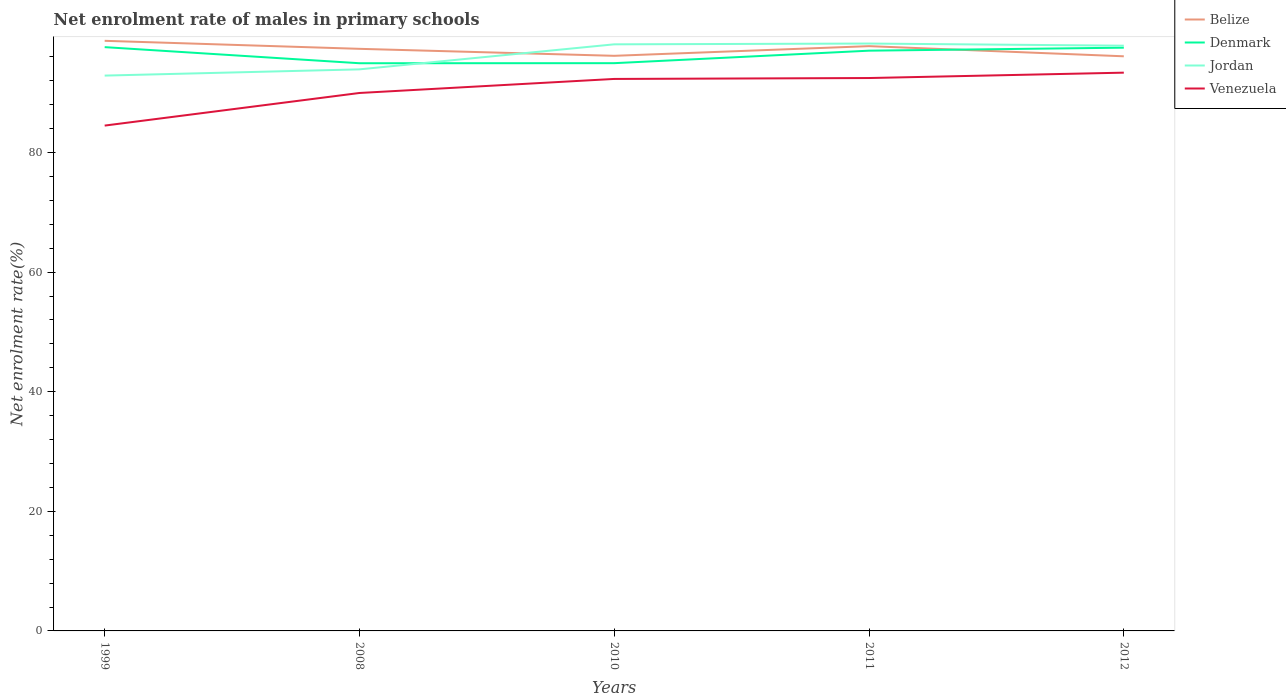Does the line corresponding to Venezuela intersect with the line corresponding to Belize?
Provide a succinct answer. No. Is the number of lines equal to the number of legend labels?
Ensure brevity in your answer.  Yes. Across all years, what is the maximum net enrolment rate of males in primary schools in Venezuela?
Offer a terse response. 84.51. In which year was the net enrolment rate of males in primary schools in Belize maximum?
Your response must be concise. 2012. What is the total net enrolment rate of males in primary schools in Venezuela in the graph?
Your answer should be compact. -2.35. What is the difference between the highest and the second highest net enrolment rate of males in primary schools in Belize?
Give a very brief answer. 2.59. What is the difference between the highest and the lowest net enrolment rate of males in primary schools in Denmark?
Your answer should be compact. 3. How many lines are there?
Provide a short and direct response. 4. How many years are there in the graph?
Keep it short and to the point. 5. Does the graph contain grids?
Give a very brief answer. No. Where does the legend appear in the graph?
Make the answer very short. Top right. How many legend labels are there?
Your answer should be compact. 4. What is the title of the graph?
Your response must be concise. Net enrolment rate of males in primary schools. What is the label or title of the X-axis?
Your response must be concise. Years. What is the label or title of the Y-axis?
Offer a very short reply. Net enrolment rate(%). What is the Net enrolment rate(%) of Belize in 1999?
Your answer should be compact. 98.68. What is the Net enrolment rate(%) in Denmark in 1999?
Offer a terse response. 97.63. What is the Net enrolment rate(%) in Jordan in 1999?
Your answer should be compact. 92.87. What is the Net enrolment rate(%) of Venezuela in 1999?
Your response must be concise. 84.51. What is the Net enrolment rate(%) of Belize in 2008?
Your response must be concise. 97.34. What is the Net enrolment rate(%) in Denmark in 2008?
Give a very brief answer. 94.93. What is the Net enrolment rate(%) in Jordan in 2008?
Your answer should be compact. 93.91. What is the Net enrolment rate(%) of Venezuela in 2008?
Offer a very short reply. 89.96. What is the Net enrolment rate(%) of Belize in 2010?
Keep it short and to the point. 96.17. What is the Net enrolment rate(%) of Denmark in 2010?
Offer a very short reply. 94.95. What is the Net enrolment rate(%) in Jordan in 2010?
Offer a very short reply. 98.1. What is the Net enrolment rate(%) of Venezuela in 2010?
Your response must be concise. 92.31. What is the Net enrolment rate(%) in Belize in 2011?
Offer a very short reply. 97.79. What is the Net enrolment rate(%) in Denmark in 2011?
Your response must be concise. 97.03. What is the Net enrolment rate(%) of Jordan in 2011?
Provide a succinct answer. 98.23. What is the Net enrolment rate(%) of Venezuela in 2011?
Your response must be concise. 92.46. What is the Net enrolment rate(%) in Belize in 2012?
Your answer should be very brief. 96.09. What is the Net enrolment rate(%) of Denmark in 2012?
Offer a very short reply. 97.54. What is the Net enrolment rate(%) of Jordan in 2012?
Your answer should be very brief. 97.87. What is the Net enrolment rate(%) in Venezuela in 2012?
Your answer should be compact. 93.36. Across all years, what is the maximum Net enrolment rate(%) of Belize?
Your answer should be very brief. 98.68. Across all years, what is the maximum Net enrolment rate(%) in Denmark?
Your answer should be compact. 97.63. Across all years, what is the maximum Net enrolment rate(%) of Jordan?
Offer a terse response. 98.23. Across all years, what is the maximum Net enrolment rate(%) in Venezuela?
Your response must be concise. 93.36. Across all years, what is the minimum Net enrolment rate(%) in Belize?
Make the answer very short. 96.09. Across all years, what is the minimum Net enrolment rate(%) in Denmark?
Make the answer very short. 94.93. Across all years, what is the minimum Net enrolment rate(%) in Jordan?
Your response must be concise. 92.87. Across all years, what is the minimum Net enrolment rate(%) in Venezuela?
Make the answer very short. 84.51. What is the total Net enrolment rate(%) in Belize in the graph?
Offer a terse response. 486.09. What is the total Net enrolment rate(%) in Denmark in the graph?
Your response must be concise. 482.08. What is the total Net enrolment rate(%) of Jordan in the graph?
Your response must be concise. 480.97. What is the total Net enrolment rate(%) of Venezuela in the graph?
Provide a succinct answer. 452.59. What is the difference between the Net enrolment rate(%) of Belize in 1999 and that in 2008?
Give a very brief answer. 1.34. What is the difference between the Net enrolment rate(%) in Denmark in 1999 and that in 2008?
Your answer should be very brief. 2.69. What is the difference between the Net enrolment rate(%) of Jordan in 1999 and that in 2008?
Offer a terse response. -1.04. What is the difference between the Net enrolment rate(%) of Venezuela in 1999 and that in 2008?
Make the answer very short. -5.45. What is the difference between the Net enrolment rate(%) of Belize in 1999 and that in 2010?
Your answer should be very brief. 2.51. What is the difference between the Net enrolment rate(%) in Denmark in 1999 and that in 2010?
Your response must be concise. 2.68. What is the difference between the Net enrolment rate(%) of Jordan in 1999 and that in 2010?
Provide a short and direct response. -5.23. What is the difference between the Net enrolment rate(%) of Venezuela in 1999 and that in 2010?
Your response must be concise. -7.8. What is the difference between the Net enrolment rate(%) of Belize in 1999 and that in 2011?
Offer a very short reply. 0.89. What is the difference between the Net enrolment rate(%) in Denmark in 1999 and that in 2011?
Your answer should be compact. 0.59. What is the difference between the Net enrolment rate(%) of Jordan in 1999 and that in 2011?
Offer a very short reply. -5.36. What is the difference between the Net enrolment rate(%) in Venezuela in 1999 and that in 2011?
Keep it short and to the point. -7.95. What is the difference between the Net enrolment rate(%) of Belize in 1999 and that in 2012?
Your answer should be very brief. 2.59. What is the difference between the Net enrolment rate(%) of Denmark in 1999 and that in 2012?
Your answer should be compact. 0.09. What is the difference between the Net enrolment rate(%) in Jordan in 1999 and that in 2012?
Your answer should be compact. -5. What is the difference between the Net enrolment rate(%) of Venezuela in 1999 and that in 2012?
Offer a terse response. -8.85. What is the difference between the Net enrolment rate(%) of Belize in 2008 and that in 2010?
Your answer should be very brief. 1.17. What is the difference between the Net enrolment rate(%) of Denmark in 2008 and that in 2010?
Provide a succinct answer. -0.01. What is the difference between the Net enrolment rate(%) in Jordan in 2008 and that in 2010?
Your response must be concise. -4.19. What is the difference between the Net enrolment rate(%) of Venezuela in 2008 and that in 2010?
Your answer should be compact. -2.35. What is the difference between the Net enrolment rate(%) of Belize in 2008 and that in 2011?
Offer a terse response. -0.45. What is the difference between the Net enrolment rate(%) of Denmark in 2008 and that in 2011?
Your answer should be compact. -2.1. What is the difference between the Net enrolment rate(%) of Jordan in 2008 and that in 2011?
Keep it short and to the point. -4.32. What is the difference between the Net enrolment rate(%) of Venezuela in 2008 and that in 2011?
Your answer should be compact. -2.5. What is the difference between the Net enrolment rate(%) in Belize in 2008 and that in 2012?
Offer a very short reply. 1.25. What is the difference between the Net enrolment rate(%) in Denmark in 2008 and that in 2012?
Offer a very short reply. -2.6. What is the difference between the Net enrolment rate(%) of Jordan in 2008 and that in 2012?
Provide a succinct answer. -3.96. What is the difference between the Net enrolment rate(%) in Venezuela in 2008 and that in 2012?
Your answer should be very brief. -3.4. What is the difference between the Net enrolment rate(%) in Belize in 2010 and that in 2011?
Provide a succinct answer. -1.62. What is the difference between the Net enrolment rate(%) in Denmark in 2010 and that in 2011?
Your answer should be very brief. -2.09. What is the difference between the Net enrolment rate(%) in Jordan in 2010 and that in 2011?
Make the answer very short. -0.13. What is the difference between the Net enrolment rate(%) in Venezuela in 2010 and that in 2011?
Your answer should be compact. -0.15. What is the difference between the Net enrolment rate(%) of Belize in 2010 and that in 2012?
Ensure brevity in your answer.  0.08. What is the difference between the Net enrolment rate(%) of Denmark in 2010 and that in 2012?
Offer a very short reply. -2.59. What is the difference between the Net enrolment rate(%) in Jordan in 2010 and that in 2012?
Your answer should be compact. 0.23. What is the difference between the Net enrolment rate(%) in Venezuela in 2010 and that in 2012?
Your answer should be very brief. -1.05. What is the difference between the Net enrolment rate(%) in Belize in 2011 and that in 2012?
Offer a very short reply. 1.7. What is the difference between the Net enrolment rate(%) of Denmark in 2011 and that in 2012?
Offer a terse response. -0.5. What is the difference between the Net enrolment rate(%) in Jordan in 2011 and that in 2012?
Keep it short and to the point. 0.36. What is the difference between the Net enrolment rate(%) of Venezuela in 2011 and that in 2012?
Ensure brevity in your answer.  -0.9. What is the difference between the Net enrolment rate(%) in Belize in 1999 and the Net enrolment rate(%) in Denmark in 2008?
Offer a very short reply. 3.75. What is the difference between the Net enrolment rate(%) in Belize in 1999 and the Net enrolment rate(%) in Jordan in 2008?
Offer a very short reply. 4.77. What is the difference between the Net enrolment rate(%) in Belize in 1999 and the Net enrolment rate(%) in Venezuela in 2008?
Offer a very short reply. 8.72. What is the difference between the Net enrolment rate(%) of Denmark in 1999 and the Net enrolment rate(%) of Jordan in 2008?
Ensure brevity in your answer.  3.72. What is the difference between the Net enrolment rate(%) in Denmark in 1999 and the Net enrolment rate(%) in Venezuela in 2008?
Your answer should be very brief. 7.67. What is the difference between the Net enrolment rate(%) in Jordan in 1999 and the Net enrolment rate(%) in Venezuela in 2008?
Your response must be concise. 2.91. What is the difference between the Net enrolment rate(%) of Belize in 1999 and the Net enrolment rate(%) of Denmark in 2010?
Make the answer very short. 3.74. What is the difference between the Net enrolment rate(%) in Belize in 1999 and the Net enrolment rate(%) in Jordan in 2010?
Make the answer very short. 0.59. What is the difference between the Net enrolment rate(%) in Belize in 1999 and the Net enrolment rate(%) in Venezuela in 2010?
Offer a terse response. 6.37. What is the difference between the Net enrolment rate(%) in Denmark in 1999 and the Net enrolment rate(%) in Jordan in 2010?
Your answer should be very brief. -0.47. What is the difference between the Net enrolment rate(%) in Denmark in 1999 and the Net enrolment rate(%) in Venezuela in 2010?
Provide a short and direct response. 5.32. What is the difference between the Net enrolment rate(%) in Jordan in 1999 and the Net enrolment rate(%) in Venezuela in 2010?
Offer a very short reply. 0.56. What is the difference between the Net enrolment rate(%) of Belize in 1999 and the Net enrolment rate(%) of Denmark in 2011?
Your answer should be compact. 1.65. What is the difference between the Net enrolment rate(%) of Belize in 1999 and the Net enrolment rate(%) of Jordan in 2011?
Your answer should be compact. 0.46. What is the difference between the Net enrolment rate(%) of Belize in 1999 and the Net enrolment rate(%) of Venezuela in 2011?
Ensure brevity in your answer.  6.22. What is the difference between the Net enrolment rate(%) of Denmark in 1999 and the Net enrolment rate(%) of Jordan in 2011?
Provide a short and direct response. -0.6. What is the difference between the Net enrolment rate(%) of Denmark in 1999 and the Net enrolment rate(%) of Venezuela in 2011?
Provide a short and direct response. 5.17. What is the difference between the Net enrolment rate(%) in Jordan in 1999 and the Net enrolment rate(%) in Venezuela in 2011?
Keep it short and to the point. 0.41. What is the difference between the Net enrolment rate(%) in Belize in 1999 and the Net enrolment rate(%) in Denmark in 2012?
Provide a succinct answer. 1.15. What is the difference between the Net enrolment rate(%) of Belize in 1999 and the Net enrolment rate(%) of Jordan in 2012?
Make the answer very short. 0.81. What is the difference between the Net enrolment rate(%) in Belize in 1999 and the Net enrolment rate(%) in Venezuela in 2012?
Your response must be concise. 5.33. What is the difference between the Net enrolment rate(%) in Denmark in 1999 and the Net enrolment rate(%) in Jordan in 2012?
Make the answer very short. -0.24. What is the difference between the Net enrolment rate(%) of Denmark in 1999 and the Net enrolment rate(%) of Venezuela in 2012?
Your answer should be very brief. 4.27. What is the difference between the Net enrolment rate(%) in Jordan in 1999 and the Net enrolment rate(%) in Venezuela in 2012?
Your response must be concise. -0.49. What is the difference between the Net enrolment rate(%) of Belize in 2008 and the Net enrolment rate(%) of Denmark in 2010?
Provide a succinct answer. 2.4. What is the difference between the Net enrolment rate(%) in Belize in 2008 and the Net enrolment rate(%) in Jordan in 2010?
Your answer should be very brief. -0.75. What is the difference between the Net enrolment rate(%) of Belize in 2008 and the Net enrolment rate(%) of Venezuela in 2010?
Make the answer very short. 5.03. What is the difference between the Net enrolment rate(%) of Denmark in 2008 and the Net enrolment rate(%) of Jordan in 2010?
Provide a short and direct response. -3.16. What is the difference between the Net enrolment rate(%) of Denmark in 2008 and the Net enrolment rate(%) of Venezuela in 2010?
Offer a very short reply. 2.63. What is the difference between the Net enrolment rate(%) in Jordan in 2008 and the Net enrolment rate(%) in Venezuela in 2010?
Make the answer very short. 1.6. What is the difference between the Net enrolment rate(%) of Belize in 2008 and the Net enrolment rate(%) of Denmark in 2011?
Keep it short and to the point. 0.31. What is the difference between the Net enrolment rate(%) of Belize in 2008 and the Net enrolment rate(%) of Jordan in 2011?
Provide a succinct answer. -0.88. What is the difference between the Net enrolment rate(%) of Belize in 2008 and the Net enrolment rate(%) of Venezuela in 2011?
Offer a very short reply. 4.88. What is the difference between the Net enrolment rate(%) in Denmark in 2008 and the Net enrolment rate(%) in Jordan in 2011?
Your answer should be very brief. -3.29. What is the difference between the Net enrolment rate(%) of Denmark in 2008 and the Net enrolment rate(%) of Venezuela in 2011?
Provide a short and direct response. 2.48. What is the difference between the Net enrolment rate(%) of Jordan in 2008 and the Net enrolment rate(%) of Venezuela in 2011?
Your answer should be very brief. 1.45. What is the difference between the Net enrolment rate(%) in Belize in 2008 and the Net enrolment rate(%) in Denmark in 2012?
Give a very brief answer. -0.19. What is the difference between the Net enrolment rate(%) of Belize in 2008 and the Net enrolment rate(%) of Jordan in 2012?
Keep it short and to the point. -0.53. What is the difference between the Net enrolment rate(%) in Belize in 2008 and the Net enrolment rate(%) in Venezuela in 2012?
Your response must be concise. 3.99. What is the difference between the Net enrolment rate(%) in Denmark in 2008 and the Net enrolment rate(%) in Jordan in 2012?
Make the answer very short. -2.93. What is the difference between the Net enrolment rate(%) of Denmark in 2008 and the Net enrolment rate(%) of Venezuela in 2012?
Your answer should be very brief. 1.58. What is the difference between the Net enrolment rate(%) in Jordan in 2008 and the Net enrolment rate(%) in Venezuela in 2012?
Your answer should be compact. 0.55. What is the difference between the Net enrolment rate(%) of Belize in 2010 and the Net enrolment rate(%) of Denmark in 2011?
Your answer should be compact. -0.86. What is the difference between the Net enrolment rate(%) in Belize in 2010 and the Net enrolment rate(%) in Jordan in 2011?
Offer a terse response. -2.05. What is the difference between the Net enrolment rate(%) of Belize in 2010 and the Net enrolment rate(%) of Venezuela in 2011?
Your response must be concise. 3.72. What is the difference between the Net enrolment rate(%) in Denmark in 2010 and the Net enrolment rate(%) in Jordan in 2011?
Provide a short and direct response. -3.28. What is the difference between the Net enrolment rate(%) in Denmark in 2010 and the Net enrolment rate(%) in Venezuela in 2011?
Your response must be concise. 2.49. What is the difference between the Net enrolment rate(%) in Jordan in 2010 and the Net enrolment rate(%) in Venezuela in 2011?
Make the answer very short. 5.64. What is the difference between the Net enrolment rate(%) in Belize in 2010 and the Net enrolment rate(%) in Denmark in 2012?
Make the answer very short. -1.36. What is the difference between the Net enrolment rate(%) of Belize in 2010 and the Net enrolment rate(%) of Jordan in 2012?
Offer a very short reply. -1.7. What is the difference between the Net enrolment rate(%) in Belize in 2010 and the Net enrolment rate(%) in Venezuela in 2012?
Your answer should be compact. 2.82. What is the difference between the Net enrolment rate(%) in Denmark in 2010 and the Net enrolment rate(%) in Jordan in 2012?
Provide a succinct answer. -2.92. What is the difference between the Net enrolment rate(%) of Denmark in 2010 and the Net enrolment rate(%) of Venezuela in 2012?
Your answer should be very brief. 1.59. What is the difference between the Net enrolment rate(%) in Jordan in 2010 and the Net enrolment rate(%) in Venezuela in 2012?
Your answer should be very brief. 4.74. What is the difference between the Net enrolment rate(%) in Belize in 2011 and the Net enrolment rate(%) in Denmark in 2012?
Provide a succinct answer. 0.26. What is the difference between the Net enrolment rate(%) in Belize in 2011 and the Net enrolment rate(%) in Jordan in 2012?
Ensure brevity in your answer.  -0.08. What is the difference between the Net enrolment rate(%) of Belize in 2011 and the Net enrolment rate(%) of Venezuela in 2012?
Your response must be concise. 4.44. What is the difference between the Net enrolment rate(%) of Denmark in 2011 and the Net enrolment rate(%) of Jordan in 2012?
Offer a terse response. -0.84. What is the difference between the Net enrolment rate(%) in Denmark in 2011 and the Net enrolment rate(%) in Venezuela in 2012?
Offer a very short reply. 3.68. What is the difference between the Net enrolment rate(%) in Jordan in 2011 and the Net enrolment rate(%) in Venezuela in 2012?
Your response must be concise. 4.87. What is the average Net enrolment rate(%) of Belize per year?
Make the answer very short. 97.22. What is the average Net enrolment rate(%) in Denmark per year?
Keep it short and to the point. 96.42. What is the average Net enrolment rate(%) of Jordan per year?
Give a very brief answer. 96.19. What is the average Net enrolment rate(%) of Venezuela per year?
Offer a terse response. 90.52. In the year 1999, what is the difference between the Net enrolment rate(%) of Belize and Net enrolment rate(%) of Denmark?
Keep it short and to the point. 1.06. In the year 1999, what is the difference between the Net enrolment rate(%) in Belize and Net enrolment rate(%) in Jordan?
Give a very brief answer. 5.82. In the year 1999, what is the difference between the Net enrolment rate(%) of Belize and Net enrolment rate(%) of Venezuela?
Provide a short and direct response. 14.18. In the year 1999, what is the difference between the Net enrolment rate(%) in Denmark and Net enrolment rate(%) in Jordan?
Your answer should be very brief. 4.76. In the year 1999, what is the difference between the Net enrolment rate(%) of Denmark and Net enrolment rate(%) of Venezuela?
Offer a very short reply. 13.12. In the year 1999, what is the difference between the Net enrolment rate(%) of Jordan and Net enrolment rate(%) of Venezuela?
Provide a succinct answer. 8.36. In the year 2008, what is the difference between the Net enrolment rate(%) of Belize and Net enrolment rate(%) of Denmark?
Ensure brevity in your answer.  2.41. In the year 2008, what is the difference between the Net enrolment rate(%) in Belize and Net enrolment rate(%) in Jordan?
Your answer should be very brief. 3.43. In the year 2008, what is the difference between the Net enrolment rate(%) of Belize and Net enrolment rate(%) of Venezuela?
Your answer should be very brief. 7.38. In the year 2008, what is the difference between the Net enrolment rate(%) of Denmark and Net enrolment rate(%) of Jordan?
Offer a very short reply. 1.02. In the year 2008, what is the difference between the Net enrolment rate(%) of Denmark and Net enrolment rate(%) of Venezuela?
Ensure brevity in your answer.  4.97. In the year 2008, what is the difference between the Net enrolment rate(%) in Jordan and Net enrolment rate(%) in Venezuela?
Provide a succinct answer. 3.95. In the year 2010, what is the difference between the Net enrolment rate(%) in Belize and Net enrolment rate(%) in Denmark?
Provide a short and direct response. 1.23. In the year 2010, what is the difference between the Net enrolment rate(%) of Belize and Net enrolment rate(%) of Jordan?
Ensure brevity in your answer.  -1.92. In the year 2010, what is the difference between the Net enrolment rate(%) in Belize and Net enrolment rate(%) in Venezuela?
Offer a terse response. 3.86. In the year 2010, what is the difference between the Net enrolment rate(%) in Denmark and Net enrolment rate(%) in Jordan?
Give a very brief answer. -3.15. In the year 2010, what is the difference between the Net enrolment rate(%) of Denmark and Net enrolment rate(%) of Venezuela?
Keep it short and to the point. 2.64. In the year 2010, what is the difference between the Net enrolment rate(%) in Jordan and Net enrolment rate(%) in Venezuela?
Your answer should be very brief. 5.79. In the year 2011, what is the difference between the Net enrolment rate(%) of Belize and Net enrolment rate(%) of Denmark?
Provide a short and direct response. 0.76. In the year 2011, what is the difference between the Net enrolment rate(%) of Belize and Net enrolment rate(%) of Jordan?
Provide a succinct answer. -0.43. In the year 2011, what is the difference between the Net enrolment rate(%) in Belize and Net enrolment rate(%) in Venezuela?
Keep it short and to the point. 5.33. In the year 2011, what is the difference between the Net enrolment rate(%) in Denmark and Net enrolment rate(%) in Jordan?
Give a very brief answer. -1.19. In the year 2011, what is the difference between the Net enrolment rate(%) of Denmark and Net enrolment rate(%) of Venezuela?
Provide a short and direct response. 4.58. In the year 2011, what is the difference between the Net enrolment rate(%) of Jordan and Net enrolment rate(%) of Venezuela?
Provide a short and direct response. 5.77. In the year 2012, what is the difference between the Net enrolment rate(%) in Belize and Net enrolment rate(%) in Denmark?
Provide a succinct answer. -1.44. In the year 2012, what is the difference between the Net enrolment rate(%) of Belize and Net enrolment rate(%) of Jordan?
Offer a terse response. -1.78. In the year 2012, what is the difference between the Net enrolment rate(%) of Belize and Net enrolment rate(%) of Venezuela?
Offer a very short reply. 2.74. In the year 2012, what is the difference between the Net enrolment rate(%) in Denmark and Net enrolment rate(%) in Jordan?
Your response must be concise. -0.33. In the year 2012, what is the difference between the Net enrolment rate(%) in Denmark and Net enrolment rate(%) in Venezuela?
Your response must be concise. 4.18. In the year 2012, what is the difference between the Net enrolment rate(%) in Jordan and Net enrolment rate(%) in Venezuela?
Your answer should be compact. 4.51. What is the ratio of the Net enrolment rate(%) of Belize in 1999 to that in 2008?
Keep it short and to the point. 1.01. What is the ratio of the Net enrolment rate(%) of Denmark in 1999 to that in 2008?
Offer a terse response. 1.03. What is the ratio of the Net enrolment rate(%) in Jordan in 1999 to that in 2008?
Your answer should be very brief. 0.99. What is the ratio of the Net enrolment rate(%) of Venezuela in 1999 to that in 2008?
Your answer should be very brief. 0.94. What is the ratio of the Net enrolment rate(%) of Belize in 1999 to that in 2010?
Offer a very short reply. 1.03. What is the ratio of the Net enrolment rate(%) of Denmark in 1999 to that in 2010?
Provide a short and direct response. 1.03. What is the ratio of the Net enrolment rate(%) in Jordan in 1999 to that in 2010?
Ensure brevity in your answer.  0.95. What is the ratio of the Net enrolment rate(%) in Venezuela in 1999 to that in 2010?
Ensure brevity in your answer.  0.92. What is the ratio of the Net enrolment rate(%) of Belize in 1999 to that in 2011?
Make the answer very short. 1.01. What is the ratio of the Net enrolment rate(%) of Jordan in 1999 to that in 2011?
Your answer should be compact. 0.95. What is the ratio of the Net enrolment rate(%) of Venezuela in 1999 to that in 2011?
Make the answer very short. 0.91. What is the ratio of the Net enrolment rate(%) in Belize in 1999 to that in 2012?
Your answer should be compact. 1.03. What is the ratio of the Net enrolment rate(%) in Jordan in 1999 to that in 2012?
Provide a succinct answer. 0.95. What is the ratio of the Net enrolment rate(%) of Venezuela in 1999 to that in 2012?
Offer a terse response. 0.91. What is the ratio of the Net enrolment rate(%) of Belize in 2008 to that in 2010?
Ensure brevity in your answer.  1.01. What is the ratio of the Net enrolment rate(%) in Denmark in 2008 to that in 2010?
Your answer should be compact. 1. What is the ratio of the Net enrolment rate(%) of Jordan in 2008 to that in 2010?
Keep it short and to the point. 0.96. What is the ratio of the Net enrolment rate(%) of Venezuela in 2008 to that in 2010?
Your response must be concise. 0.97. What is the ratio of the Net enrolment rate(%) of Denmark in 2008 to that in 2011?
Provide a succinct answer. 0.98. What is the ratio of the Net enrolment rate(%) of Jordan in 2008 to that in 2011?
Ensure brevity in your answer.  0.96. What is the ratio of the Net enrolment rate(%) of Denmark in 2008 to that in 2012?
Give a very brief answer. 0.97. What is the ratio of the Net enrolment rate(%) in Jordan in 2008 to that in 2012?
Give a very brief answer. 0.96. What is the ratio of the Net enrolment rate(%) of Venezuela in 2008 to that in 2012?
Offer a terse response. 0.96. What is the ratio of the Net enrolment rate(%) in Belize in 2010 to that in 2011?
Provide a succinct answer. 0.98. What is the ratio of the Net enrolment rate(%) in Denmark in 2010 to that in 2011?
Your answer should be very brief. 0.98. What is the ratio of the Net enrolment rate(%) in Jordan in 2010 to that in 2011?
Ensure brevity in your answer.  1. What is the ratio of the Net enrolment rate(%) in Denmark in 2010 to that in 2012?
Offer a terse response. 0.97. What is the ratio of the Net enrolment rate(%) of Belize in 2011 to that in 2012?
Provide a succinct answer. 1.02. What is the ratio of the Net enrolment rate(%) in Jordan in 2011 to that in 2012?
Provide a short and direct response. 1. What is the difference between the highest and the second highest Net enrolment rate(%) of Belize?
Provide a succinct answer. 0.89. What is the difference between the highest and the second highest Net enrolment rate(%) in Denmark?
Give a very brief answer. 0.09. What is the difference between the highest and the second highest Net enrolment rate(%) of Jordan?
Give a very brief answer. 0.13. What is the difference between the highest and the second highest Net enrolment rate(%) of Venezuela?
Keep it short and to the point. 0.9. What is the difference between the highest and the lowest Net enrolment rate(%) of Belize?
Keep it short and to the point. 2.59. What is the difference between the highest and the lowest Net enrolment rate(%) of Denmark?
Offer a terse response. 2.69. What is the difference between the highest and the lowest Net enrolment rate(%) of Jordan?
Make the answer very short. 5.36. What is the difference between the highest and the lowest Net enrolment rate(%) in Venezuela?
Ensure brevity in your answer.  8.85. 